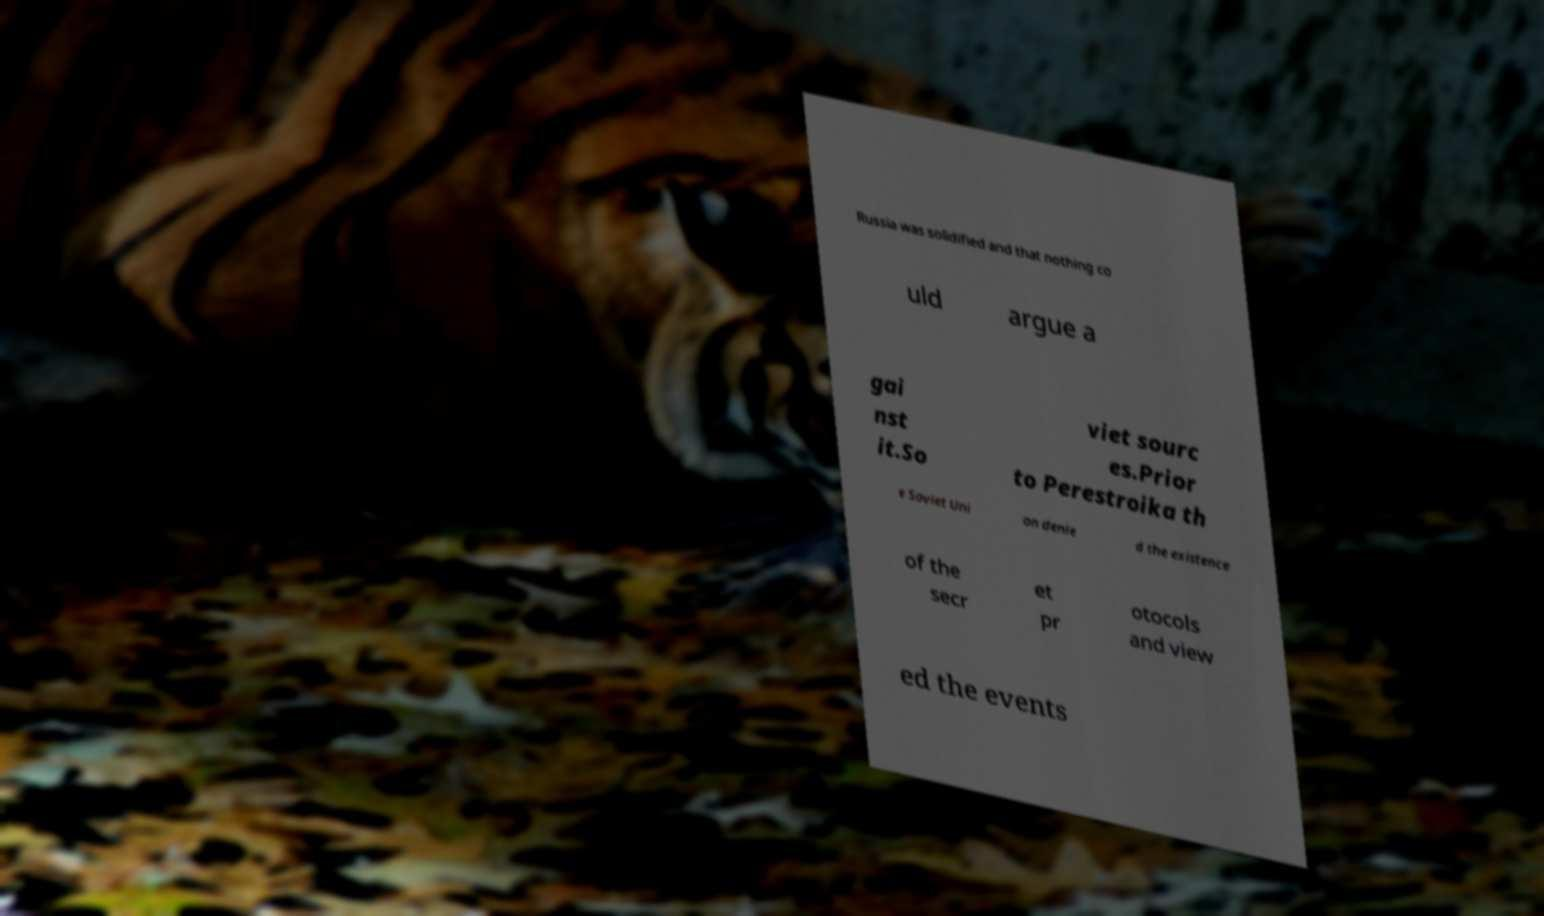There's text embedded in this image that I need extracted. Can you transcribe it verbatim? Russia was solidified and that nothing co uld argue a gai nst it.So viet sourc es.Prior to Perestroika th e Soviet Uni on denie d the existence of the secr et pr otocols and view ed the events 